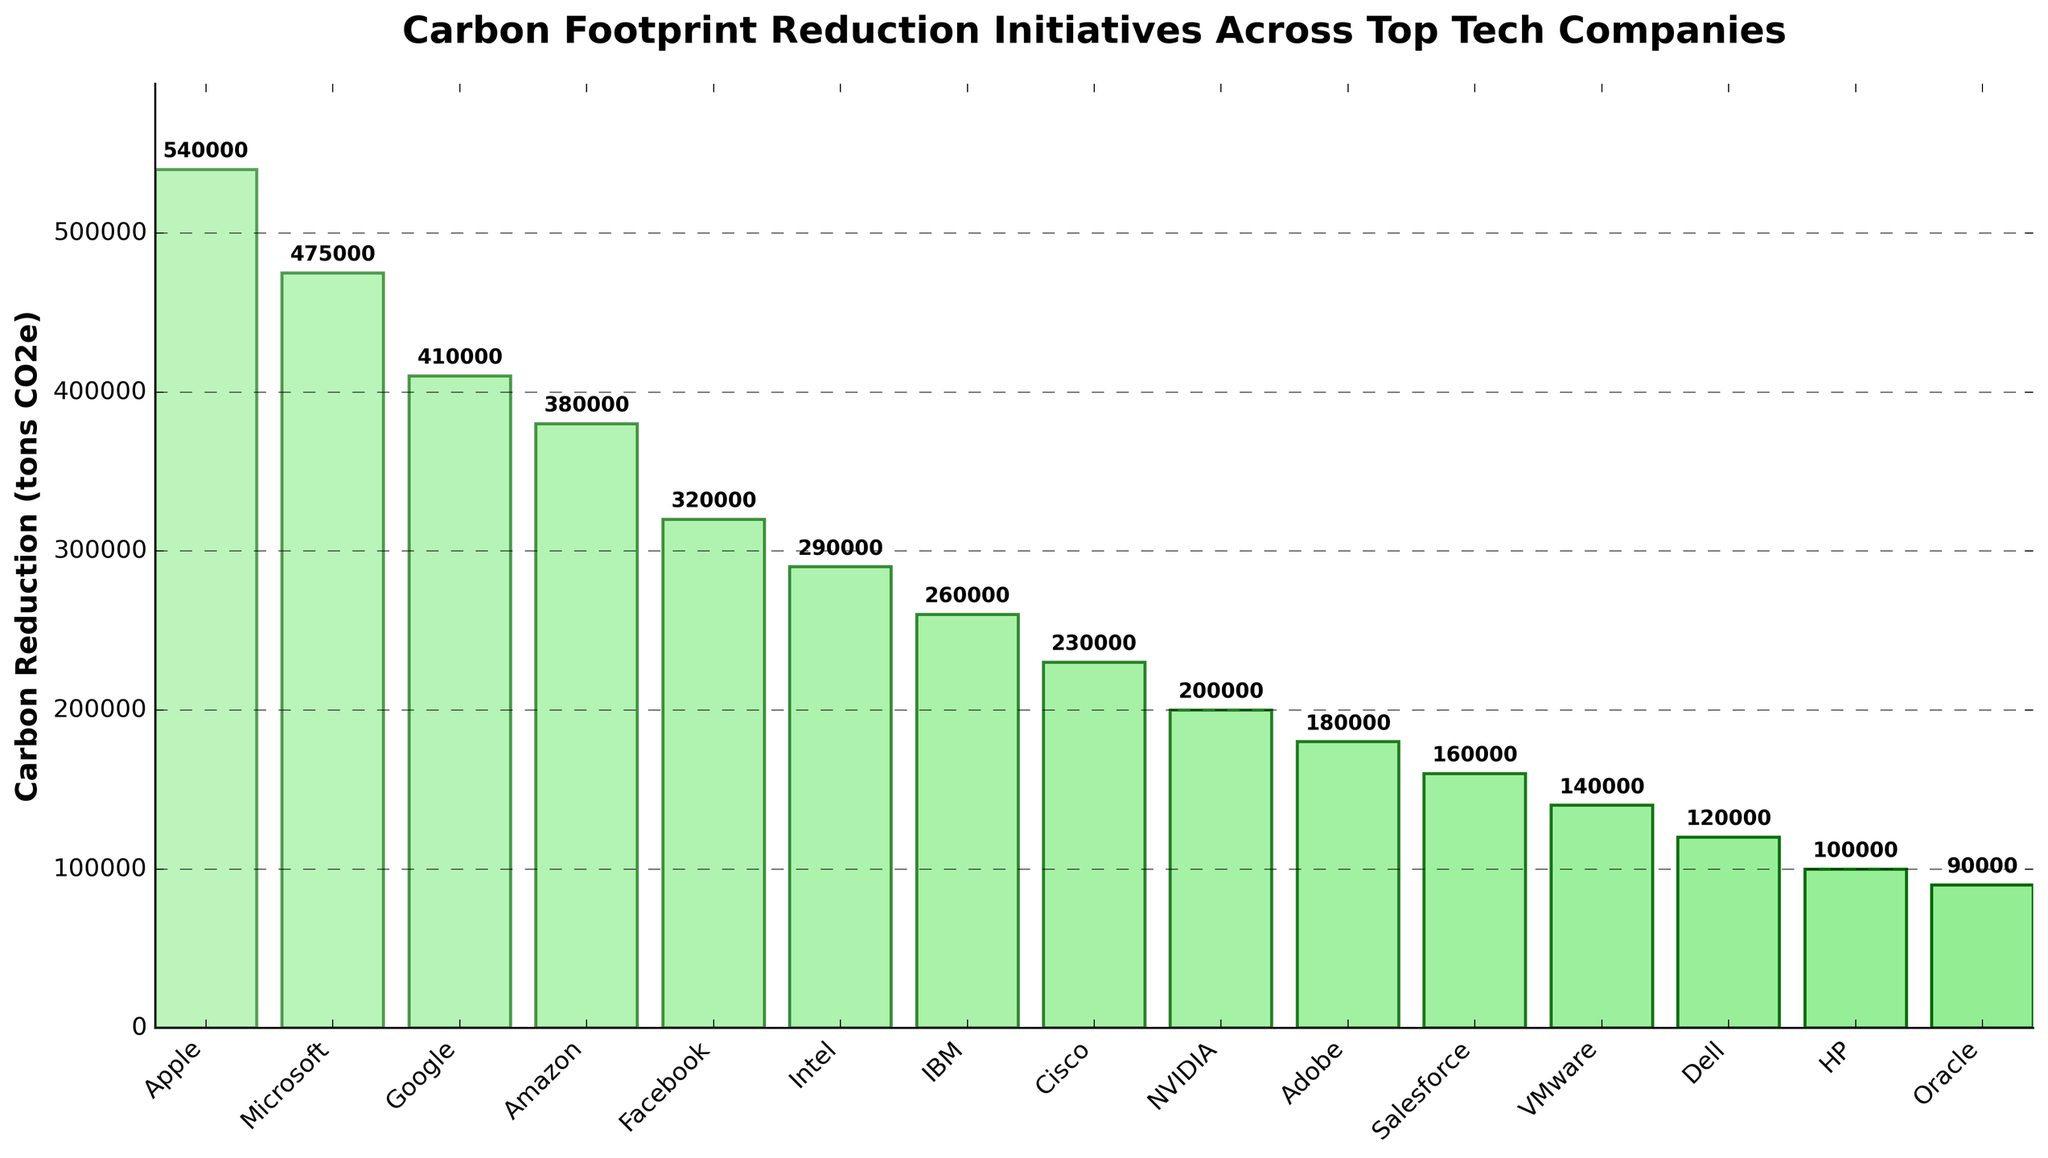What's the company with the highest carbon reduction? Look at the bar with the tallest height. The tallest bar represents Apple.
Answer: Apple Which two companies have the closest carbon reduction values? Compare the heights of the bars to identify the ones with almost similar lengths. Microsoft and Google have close values.
Answer: Microsoft and Google What's the total carbon reduction for Intel and Cisco combined? Sum the carbon reduction values for Intel and Cisco: 290,000 + 230,000 = 520,000.
Answer: 520,000 How much more carbon reduction did Amazon achieve compared to Facebook? Subtract Facebook's carbon reduction from Amazon's: 380,000 - 320,000 = 60,000.
Answer: 60,000 Which company has a carbon reduction closest to 200,000 tons? Identify the bar that is nearest to the 200,000 mark. NVIDIA has a carbon reduction value of 200,000.
Answer: NVIDIA What's the total carbon reduction for the top 3 companies combined? Sum the carbon reduction values for Apple, Microsoft, and Google: 540,000 + 475,000 + 410,000 = 1,425,000.
Answer: 1,425,000 Which company has the smallest carbon reduction? Look at the bar with the shortest height. The shortest bar represents Oracle.
Answer: Oracle What is the difference in carbon reduction between Salesforce and VMware? Subtract VMware's carbon reduction from Salesforce's: 160,000 - 140,000 = 20,000.
Answer: 20,000 How does the length of Amazon's bar compare to Intel's? Compare the heights of the bars for Amazon and Intel. Amazon's bar is taller than Intel's.
Answer: Amazon's is taller What is the average carbon reduction among all companies listed? Sum all the carbon reduction values and divide by the number of companies:
(540,000 + 475,000 + 410,000 + 380,000 + 320,000 + 290,000 + 260,000 + 230,000 + 200,000 + 180,000 + 160,000 + 140,000 + 120,000 + 100,000 + 90,000) / 15 = 3,895,000 / 15 = 259,666.67.
Answer: 259,666.67 